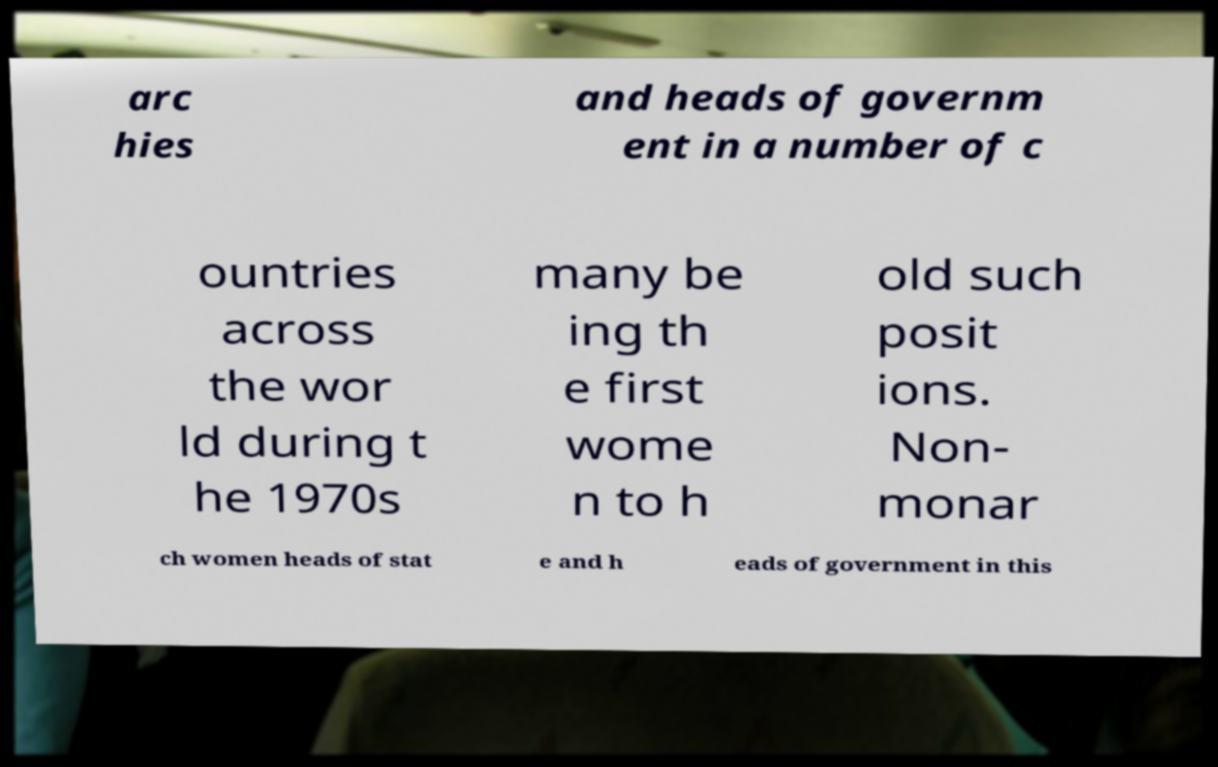There's text embedded in this image that I need extracted. Can you transcribe it verbatim? arc hies and heads of governm ent in a number of c ountries across the wor ld during t he 1970s many be ing th e first wome n to h old such posit ions. Non- monar ch women heads of stat e and h eads of government in this 